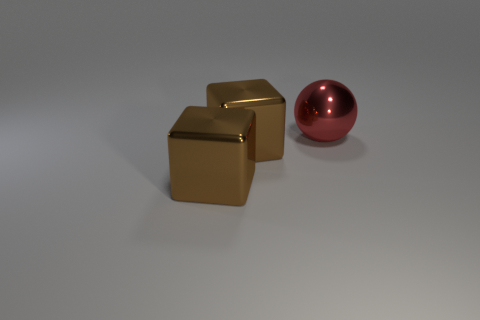Add 3 large brown shiny blocks. How many objects exist? 6 Subtract all big brown cubes. Subtract all red objects. How many objects are left? 0 Add 1 brown metallic things. How many brown metallic things are left? 3 Add 3 big red balls. How many big red balls exist? 4 Subtract 0 brown cylinders. How many objects are left? 3 Subtract all spheres. How many objects are left? 2 Subtract all purple balls. Subtract all gray blocks. How many balls are left? 1 